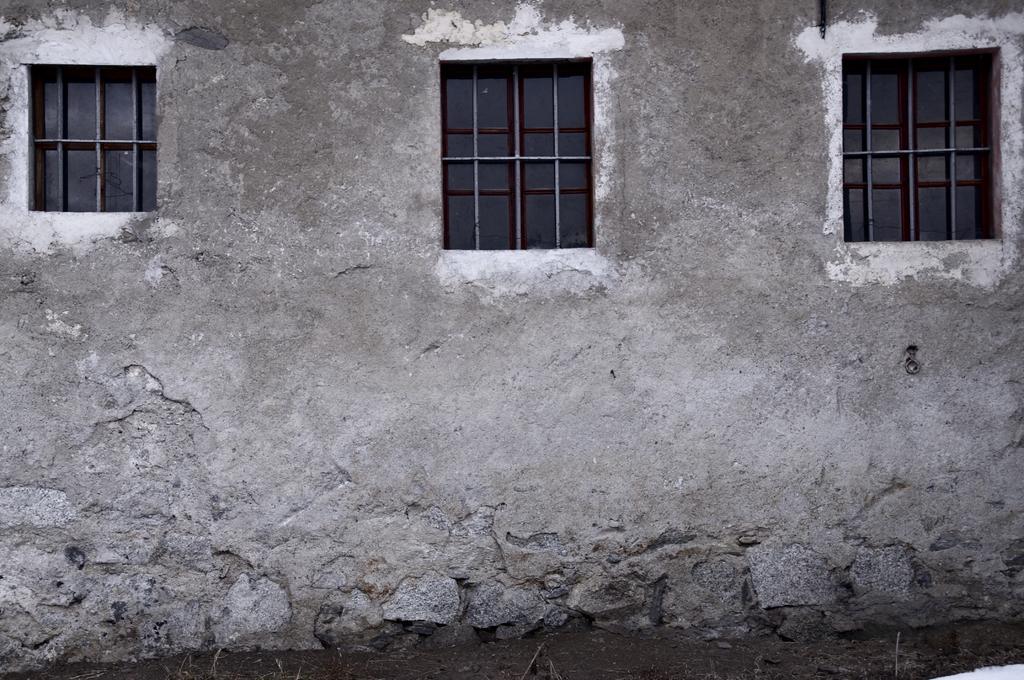Please provide a concise description of this image. In this image I can see the house, windows and the wall. 